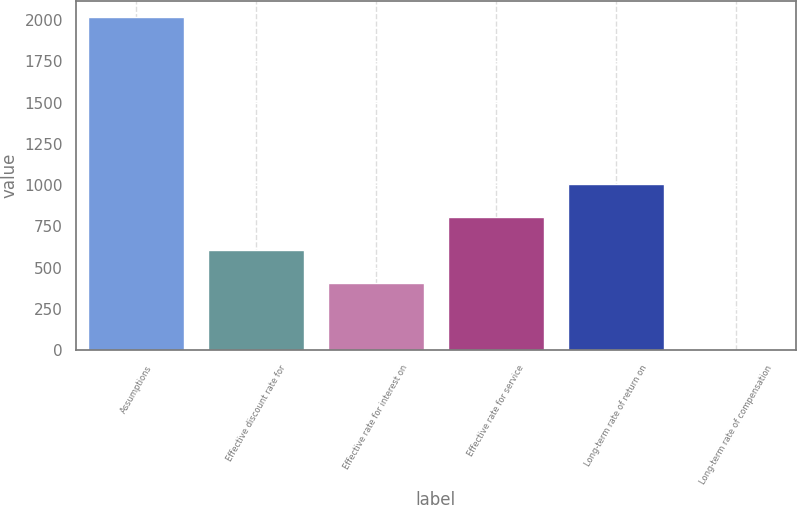Convert chart. <chart><loc_0><loc_0><loc_500><loc_500><bar_chart><fcel>Assumptions<fcel>Effective discount rate for<fcel>Effective rate for interest on<fcel>Effective rate for service<fcel>Long-term rate of return on<fcel>Long-term rate of compensation<nl><fcel>2016<fcel>606.55<fcel>405.2<fcel>807.9<fcel>1009.25<fcel>2.5<nl></chart> 